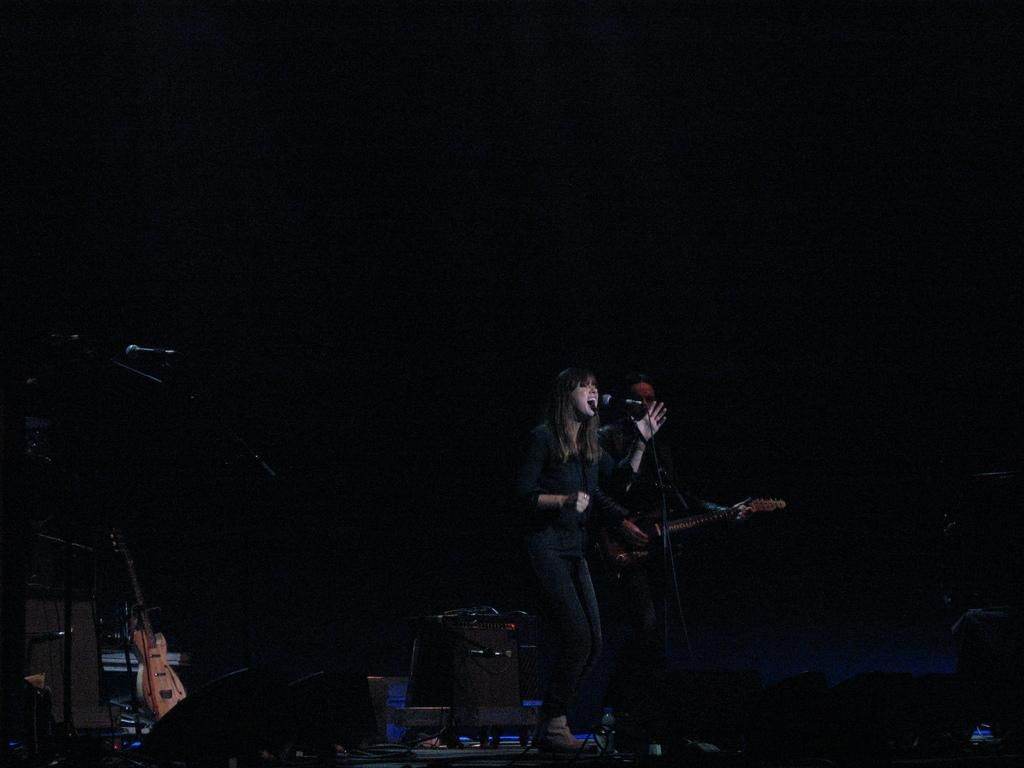Who is the main subject in the image? There is a lady in the image. What is the lady doing in the image? The lady is singing in the image. What is the lady using to amplify her voice? There is a microphone (mic) in front of the lady. Who else is present in the image? There is a person playing a guitar in the image. How many microphones are visible in the image? There are additional microphones in the image. What other items can be seen on the floor? There are guitars and other items on the floor. Can you tell me how many sisters are playing in the field in the image? There is no field or sisters present in the image; it features a lady singing and a guitar player. What type of bridge can be seen connecting the guitars in the image? There is no bridge connecting the guitars in the image; they are simply placed on the floor. 